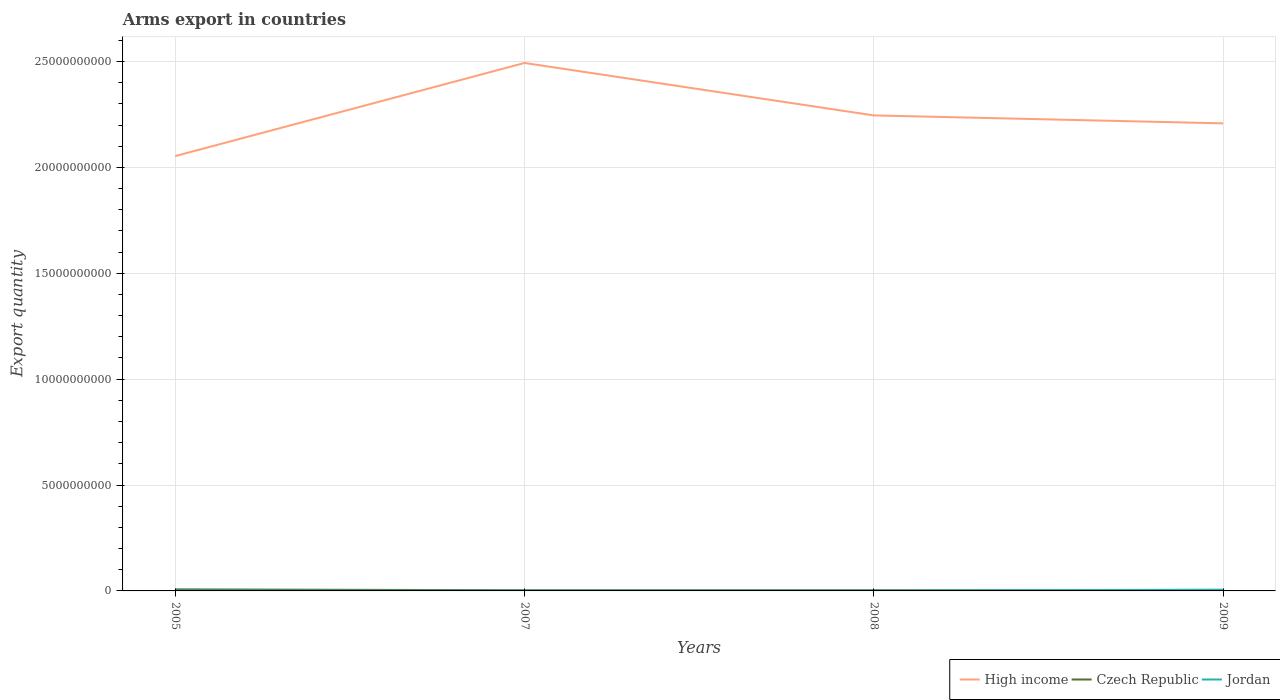Across all years, what is the maximum total arms export in Czech Republic?
Your response must be concise. 2.20e+07. What is the total total arms export in Jordan in the graph?
Your answer should be compact. -4.70e+07. What is the difference between the highest and the second highest total arms export in Jordan?
Ensure brevity in your answer.  4.80e+07. What is the difference between the highest and the lowest total arms export in High income?
Keep it short and to the point. 1. How many lines are there?
Provide a succinct answer. 3. How many years are there in the graph?
Provide a succinct answer. 4. How many legend labels are there?
Your answer should be very brief. 3. What is the title of the graph?
Provide a short and direct response. Arms export in countries. Does "St. Kitts and Nevis" appear as one of the legend labels in the graph?
Keep it short and to the point. No. What is the label or title of the Y-axis?
Offer a very short reply. Export quantity. What is the Export quantity of High income in 2005?
Keep it short and to the point. 2.05e+1. What is the Export quantity in Czech Republic in 2005?
Ensure brevity in your answer.  7.30e+07. What is the Export quantity of Jordan in 2005?
Offer a terse response. 2.00e+07. What is the Export quantity in High income in 2007?
Offer a very short reply. 2.49e+1. What is the Export quantity of Czech Republic in 2007?
Keep it short and to the point. 3.20e+07. What is the Export quantity of Jordan in 2007?
Provide a succinct answer. 1.30e+07. What is the Export quantity of High income in 2008?
Offer a terse response. 2.25e+1. What is the Export quantity in Czech Republic in 2008?
Provide a succinct answer. 3.20e+07. What is the Export quantity of High income in 2009?
Your answer should be compact. 2.21e+1. What is the Export quantity in Czech Republic in 2009?
Offer a very short reply. 2.20e+07. What is the Export quantity of Jordan in 2009?
Ensure brevity in your answer.  6.00e+07. Across all years, what is the maximum Export quantity of High income?
Keep it short and to the point. 2.49e+1. Across all years, what is the maximum Export quantity of Czech Republic?
Keep it short and to the point. 7.30e+07. Across all years, what is the maximum Export quantity in Jordan?
Provide a succinct answer. 6.00e+07. Across all years, what is the minimum Export quantity in High income?
Offer a terse response. 2.05e+1. Across all years, what is the minimum Export quantity in Czech Republic?
Ensure brevity in your answer.  2.20e+07. Across all years, what is the minimum Export quantity in Jordan?
Provide a succinct answer. 1.20e+07. What is the total Export quantity of High income in the graph?
Make the answer very short. 9.00e+1. What is the total Export quantity of Czech Republic in the graph?
Your answer should be compact. 1.59e+08. What is the total Export quantity in Jordan in the graph?
Provide a succinct answer. 1.05e+08. What is the difference between the Export quantity of High income in 2005 and that in 2007?
Provide a short and direct response. -4.40e+09. What is the difference between the Export quantity in Czech Republic in 2005 and that in 2007?
Give a very brief answer. 4.10e+07. What is the difference between the Export quantity in High income in 2005 and that in 2008?
Provide a succinct answer. -1.92e+09. What is the difference between the Export quantity in Czech Republic in 2005 and that in 2008?
Keep it short and to the point. 4.10e+07. What is the difference between the Export quantity in Jordan in 2005 and that in 2008?
Provide a succinct answer. 8.00e+06. What is the difference between the Export quantity in High income in 2005 and that in 2009?
Make the answer very short. -1.54e+09. What is the difference between the Export quantity of Czech Republic in 2005 and that in 2009?
Your answer should be very brief. 5.10e+07. What is the difference between the Export quantity of Jordan in 2005 and that in 2009?
Make the answer very short. -4.00e+07. What is the difference between the Export quantity in High income in 2007 and that in 2008?
Offer a terse response. 2.48e+09. What is the difference between the Export quantity of Jordan in 2007 and that in 2008?
Your answer should be compact. 1.00e+06. What is the difference between the Export quantity in High income in 2007 and that in 2009?
Offer a terse response. 2.85e+09. What is the difference between the Export quantity of Czech Republic in 2007 and that in 2009?
Provide a succinct answer. 1.00e+07. What is the difference between the Export quantity in Jordan in 2007 and that in 2009?
Offer a terse response. -4.70e+07. What is the difference between the Export quantity in High income in 2008 and that in 2009?
Your response must be concise. 3.75e+08. What is the difference between the Export quantity in Czech Republic in 2008 and that in 2009?
Keep it short and to the point. 1.00e+07. What is the difference between the Export quantity of Jordan in 2008 and that in 2009?
Your answer should be compact. -4.80e+07. What is the difference between the Export quantity of High income in 2005 and the Export quantity of Czech Republic in 2007?
Ensure brevity in your answer.  2.05e+1. What is the difference between the Export quantity of High income in 2005 and the Export quantity of Jordan in 2007?
Provide a succinct answer. 2.05e+1. What is the difference between the Export quantity in Czech Republic in 2005 and the Export quantity in Jordan in 2007?
Your answer should be compact. 6.00e+07. What is the difference between the Export quantity of High income in 2005 and the Export quantity of Czech Republic in 2008?
Give a very brief answer. 2.05e+1. What is the difference between the Export quantity of High income in 2005 and the Export quantity of Jordan in 2008?
Offer a terse response. 2.05e+1. What is the difference between the Export quantity in Czech Republic in 2005 and the Export quantity in Jordan in 2008?
Keep it short and to the point. 6.10e+07. What is the difference between the Export quantity in High income in 2005 and the Export quantity in Czech Republic in 2009?
Your answer should be very brief. 2.05e+1. What is the difference between the Export quantity in High income in 2005 and the Export quantity in Jordan in 2009?
Give a very brief answer. 2.05e+1. What is the difference between the Export quantity in Czech Republic in 2005 and the Export quantity in Jordan in 2009?
Your response must be concise. 1.30e+07. What is the difference between the Export quantity in High income in 2007 and the Export quantity in Czech Republic in 2008?
Offer a terse response. 2.49e+1. What is the difference between the Export quantity in High income in 2007 and the Export quantity in Jordan in 2008?
Your response must be concise. 2.49e+1. What is the difference between the Export quantity of Czech Republic in 2007 and the Export quantity of Jordan in 2008?
Ensure brevity in your answer.  2.00e+07. What is the difference between the Export quantity of High income in 2007 and the Export quantity of Czech Republic in 2009?
Provide a short and direct response. 2.49e+1. What is the difference between the Export quantity in High income in 2007 and the Export quantity in Jordan in 2009?
Provide a succinct answer. 2.49e+1. What is the difference between the Export quantity in Czech Republic in 2007 and the Export quantity in Jordan in 2009?
Offer a terse response. -2.80e+07. What is the difference between the Export quantity of High income in 2008 and the Export quantity of Czech Republic in 2009?
Offer a very short reply. 2.24e+1. What is the difference between the Export quantity in High income in 2008 and the Export quantity in Jordan in 2009?
Make the answer very short. 2.24e+1. What is the difference between the Export quantity of Czech Republic in 2008 and the Export quantity of Jordan in 2009?
Provide a short and direct response. -2.80e+07. What is the average Export quantity of High income per year?
Your answer should be compact. 2.25e+1. What is the average Export quantity in Czech Republic per year?
Keep it short and to the point. 3.98e+07. What is the average Export quantity of Jordan per year?
Offer a very short reply. 2.62e+07. In the year 2005, what is the difference between the Export quantity of High income and Export quantity of Czech Republic?
Your answer should be very brief. 2.05e+1. In the year 2005, what is the difference between the Export quantity in High income and Export quantity in Jordan?
Offer a very short reply. 2.05e+1. In the year 2005, what is the difference between the Export quantity of Czech Republic and Export quantity of Jordan?
Provide a short and direct response. 5.30e+07. In the year 2007, what is the difference between the Export quantity in High income and Export quantity in Czech Republic?
Ensure brevity in your answer.  2.49e+1. In the year 2007, what is the difference between the Export quantity in High income and Export quantity in Jordan?
Give a very brief answer. 2.49e+1. In the year 2007, what is the difference between the Export quantity of Czech Republic and Export quantity of Jordan?
Offer a very short reply. 1.90e+07. In the year 2008, what is the difference between the Export quantity in High income and Export quantity in Czech Republic?
Keep it short and to the point. 2.24e+1. In the year 2008, what is the difference between the Export quantity in High income and Export quantity in Jordan?
Provide a succinct answer. 2.24e+1. In the year 2009, what is the difference between the Export quantity of High income and Export quantity of Czech Republic?
Ensure brevity in your answer.  2.21e+1. In the year 2009, what is the difference between the Export quantity in High income and Export quantity in Jordan?
Provide a short and direct response. 2.20e+1. In the year 2009, what is the difference between the Export quantity of Czech Republic and Export quantity of Jordan?
Ensure brevity in your answer.  -3.80e+07. What is the ratio of the Export quantity of High income in 2005 to that in 2007?
Give a very brief answer. 0.82. What is the ratio of the Export quantity of Czech Republic in 2005 to that in 2007?
Keep it short and to the point. 2.28. What is the ratio of the Export quantity in Jordan in 2005 to that in 2007?
Provide a succinct answer. 1.54. What is the ratio of the Export quantity of High income in 2005 to that in 2008?
Make the answer very short. 0.91. What is the ratio of the Export quantity of Czech Republic in 2005 to that in 2008?
Keep it short and to the point. 2.28. What is the ratio of the Export quantity of Jordan in 2005 to that in 2008?
Make the answer very short. 1.67. What is the ratio of the Export quantity of Czech Republic in 2005 to that in 2009?
Offer a terse response. 3.32. What is the ratio of the Export quantity in Jordan in 2005 to that in 2009?
Your answer should be very brief. 0.33. What is the ratio of the Export quantity in High income in 2007 to that in 2008?
Your answer should be compact. 1.11. What is the ratio of the Export quantity of Czech Republic in 2007 to that in 2008?
Your answer should be compact. 1. What is the ratio of the Export quantity in Jordan in 2007 to that in 2008?
Provide a short and direct response. 1.08. What is the ratio of the Export quantity in High income in 2007 to that in 2009?
Offer a terse response. 1.13. What is the ratio of the Export quantity in Czech Republic in 2007 to that in 2009?
Your response must be concise. 1.45. What is the ratio of the Export quantity in Jordan in 2007 to that in 2009?
Offer a very short reply. 0.22. What is the ratio of the Export quantity of Czech Republic in 2008 to that in 2009?
Your response must be concise. 1.45. What is the difference between the highest and the second highest Export quantity in High income?
Ensure brevity in your answer.  2.48e+09. What is the difference between the highest and the second highest Export quantity in Czech Republic?
Offer a terse response. 4.10e+07. What is the difference between the highest and the second highest Export quantity in Jordan?
Offer a very short reply. 4.00e+07. What is the difference between the highest and the lowest Export quantity of High income?
Your answer should be very brief. 4.40e+09. What is the difference between the highest and the lowest Export quantity in Czech Republic?
Offer a very short reply. 5.10e+07. What is the difference between the highest and the lowest Export quantity of Jordan?
Your response must be concise. 4.80e+07. 